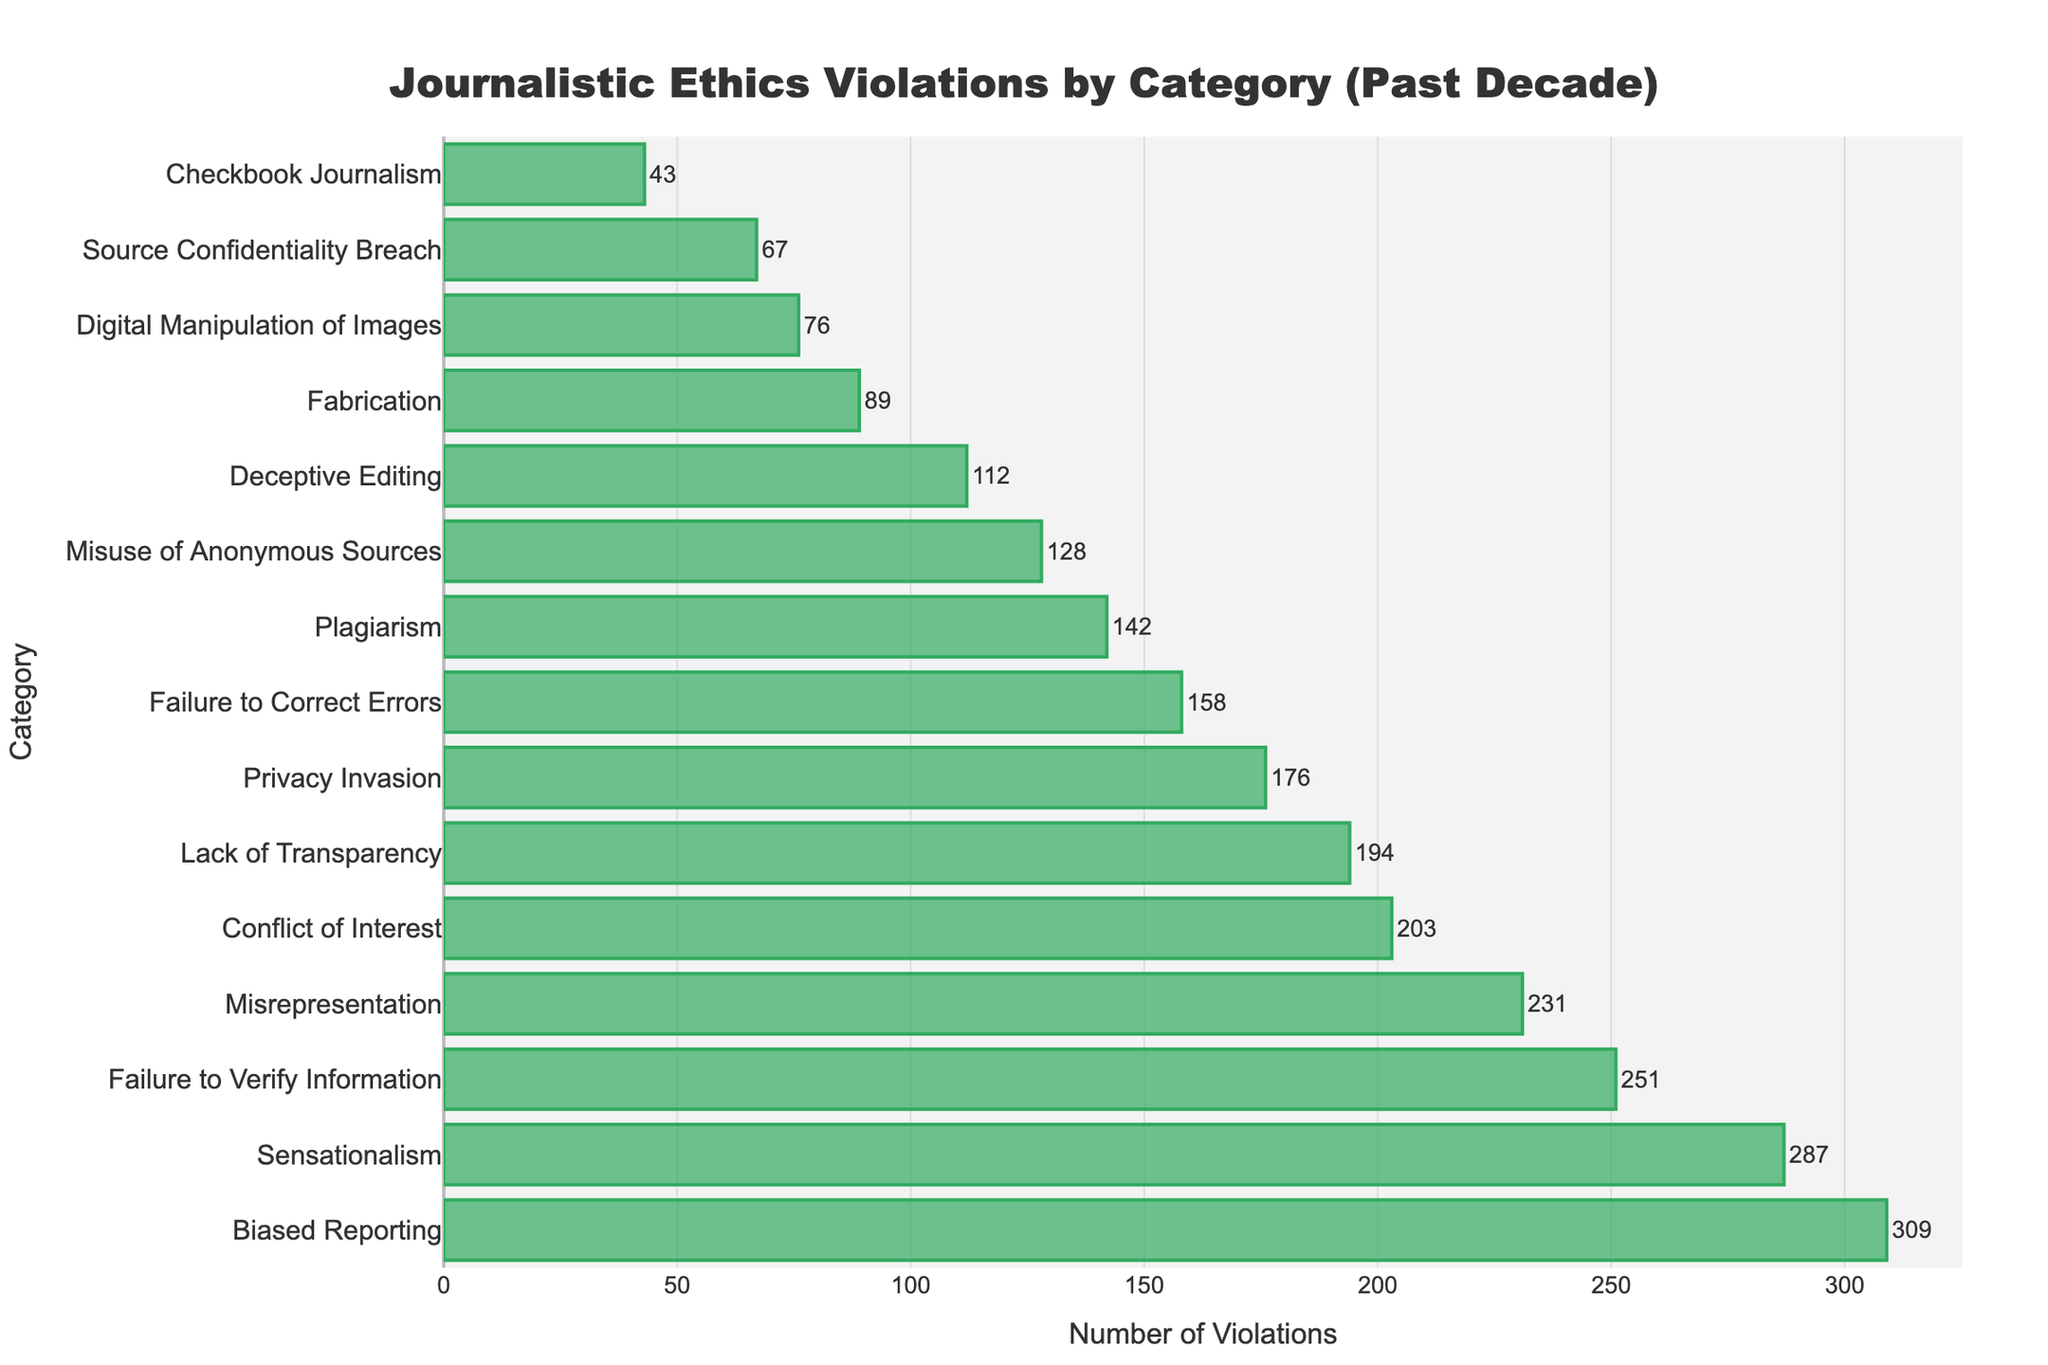Which category has the highest number of violations? Look at the bar chart and identify the bar with the longest length. The category "Biased Reporting" has the longest bar.
Answer: Biased Reporting What is the difference in the number of violations between Sensationalism and Fabrication? Find the number of violations for Sensationalism (287) and Fabrication (89) and subtract the smaller number from the larger number: 287 - 89.
Answer: 198 How many violations are there in total for Plagiarism, Fabrication, and Conflict of Interest? Add the number of violations for Plagiarism (142), Fabrication (89), and Conflict of Interest (203): 142 + 89 + 203.
Answer: 434 Which category has fewer violations, Privacy Invasion or Deceptive Editing? Compare the number of violations in Privacy Invasion (176) and Deceptive Editing (112). Deceptive Editing has fewer violations.
Answer: Deceptive Editing Which category has more violations, Lack of Transparency or Digital Manipulation of Images? Compare the number of violations in Lack of Transparency (194) and Digital Manipulation of Images (76). Lack of Transparency has more violations.
Answer: Lack of Transparency What is the combined total of violations for Privacy Invasion and Misrepresentation? Add the number of violations for Privacy Invasion (176) and Misrepresentation (231): 176 + 231.
Answer: 407 How many more violations are there in Biased Reporting compared to Source Confidentiality Breach? Subtract the number of violations for Source Confidentiality Breach (67) from the number for Biased Reporting (309): 309 - 67.
Answer: 242 What is the average number of violations across all categories? Add all the violation numbers and divide by the total number of categories (15). Sum of violations is 2456, so the average is 2456 / 15.
Answer: 163.73 Which category has the second highest number of violations? Identify the second longest bar in the chart after Biased Reporting. Sensationalism has the second longest bar.
Answer: Sensationalism 